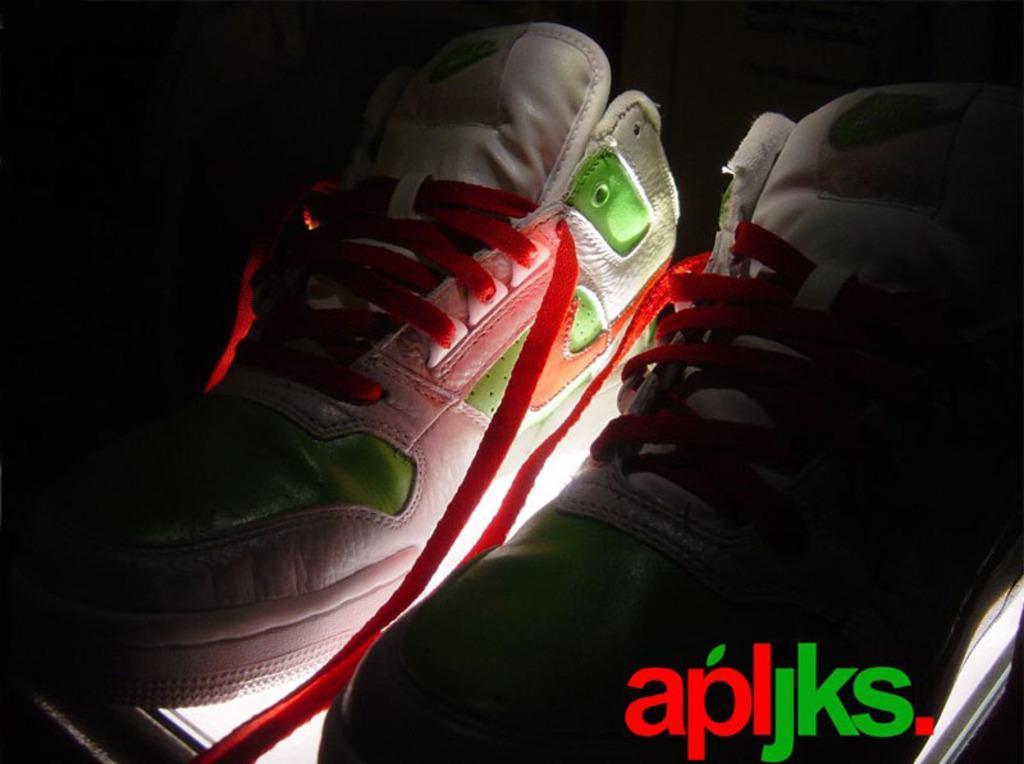What type of footwear is in the image? There is a pair of shoes in the image. What colors are the shoes? The shoes are white, red, and green in color. What can be seen in the background of the image? The background of the image is dark. What is the source of light visible below the shoes? There is light visible below the shoes. Can you tell me how many people are swimming in the image? There is no swimming or people present in the image; it features a pair of shoes with light below them. 